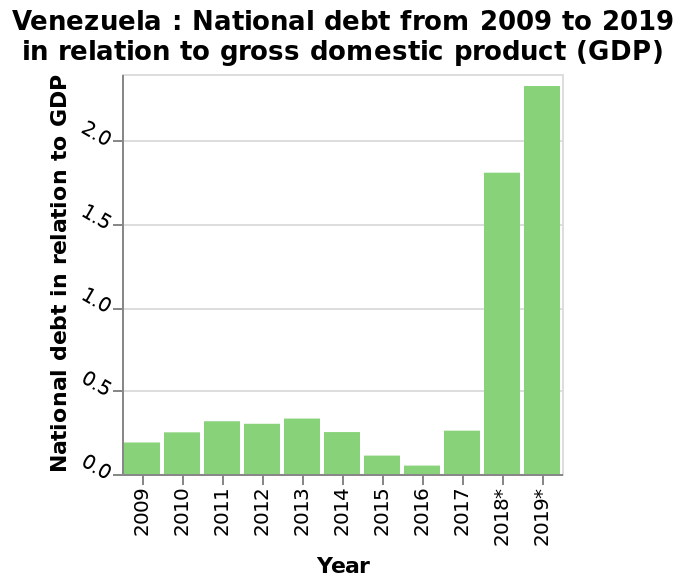<image>
What is the categorical scale used for the x-axis? The categorical scale used for the x-axis starts with 2009 and ends with 2019. Offer a thorough analysis of the image. 2018 & 2019 saw massive rise in the national debt. Was there a significant change in the national debt in 2018 and 2019? Yes, there was a massive rise in the national debt during both 2018 and 2019. Which years experienced a massive rise in the national debt?  The national debt had a substantial increase in both 2018 and 2019. 